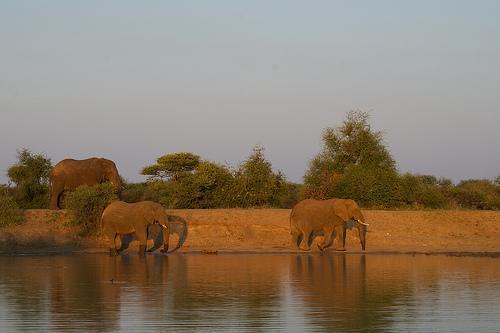How many elephants are shown?
Give a very brief answer. 3. 